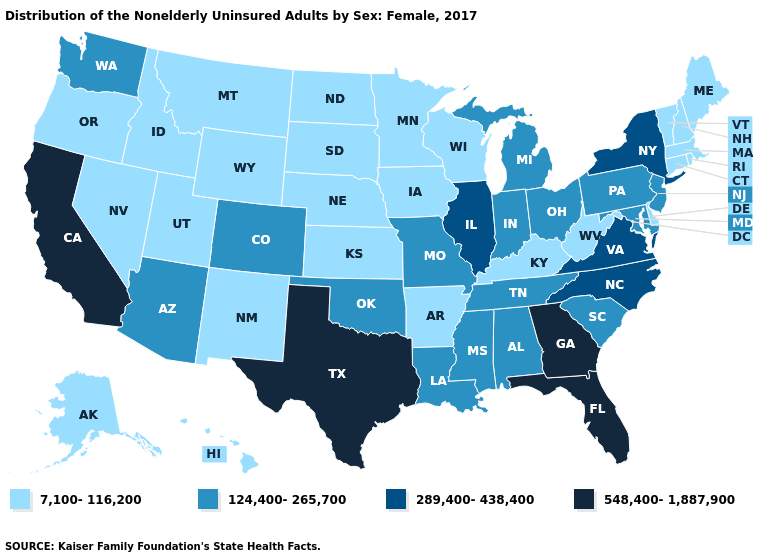What is the value of Utah?
Short answer required. 7,100-116,200. Does Wyoming have the same value as Rhode Island?
Write a very short answer. Yes. Name the states that have a value in the range 548,400-1,887,900?
Quick response, please. California, Florida, Georgia, Texas. Does California have the lowest value in the West?
Write a very short answer. No. Name the states that have a value in the range 548,400-1,887,900?
Keep it brief. California, Florida, Georgia, Texas. Name the states that have a value in the range 7,100-116,200?
Quick response, please. Alaska, Arkansas, Connecticut, Delaware, Hawaii, Idaho, Iowa, Kansas, Kentucky, Maine, Massachusetts, Minnesota, Montana, Nebraska, Nevada, New Hampshire, New Mexico, North Dakota, Oregon, Rhode Island, South Dakota, Utah, Vermont, West Virginia, Wisconsin, Wyoming. What is the value of Georgia?
Short answer required. 548,400-1,887,900. Name the states that have a value in the range 124,400-265,700?
Keep it brief. Alabama, Arizona, Colorado, Indiana, Louisiana, Maryland, Michigan, Mississippi, Missouri, New Jersey, Ohio, Oklahoma, Pennsylvania, South Carolina, Tennessee, Washington. What is the value of Colorado?
Be succinct. 124,400-265,700. Name the states that have a value in the range 7,100-116,200?
Short answer required. Alaska, Arkansas, Connecticut, Delaware, Hawaii, Idaho, Iowa, Kansas, Kentucky, Maine, Massachusetts, Minnesota, Montana, Nebraska, Nevada, New Hampshire, New Mexico, North Dakota, Oregon, Rhode Island, South Dakota, Utah, Vermont, West Virginia, Wisconsin, Wyoming. Which states have the lowest value in the USA?
Keep it brief. Alaska, Arkansas, Connecticut, Delaware, Hawaii, Idaho, Iowa, Kansas, Kentucky, Maine, Massachusetts, Minnesota, Montana, Nebraska, Nevada, New Hampshire, New Mexico, North Dakota, Oregon, Rhode Island, South Dakota, Utah, Vermont, West Virginia, Wisconsin, Wyoming. What is the value of Mississippi?
Concise answer only. 124,400-265,700. Among the states that border Nebraska , which have the lowest value?
Keep it brief. Iowa, Kansas, South Dakota, Wyoming. Name the states that have a value in the range 7,100-116,200?
Short answer required. Alaska, Arkansas, Connecticut, Delaware, Hawaii, Idaho, Iowa, Kansas, Kentucky, Maine, Massachusetts, Minnesota, Montana, Nebraska, Nevada, New Hampshire, New Mexico, North Dakota, Oregon, Rhode Island, South Dakota, Utah, Vermont, West Virginia, Wisconsin, Wyoming. What is the value of Virginia?
Answer briefly. 289,400-438,400. 